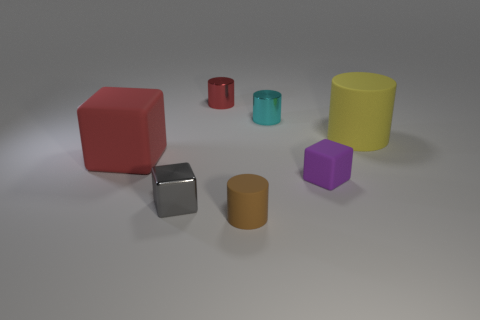Is there a red object to the right of the rubber cube that is behind the purple thing?
Make the answer very short. Yes. Are there fewer cyan shiny objects than rubber balls?
Offer a very short reply. No. How many big yellow objects have the same shape as the brown object?
Make the answer very short. 1. How many yellow things are either large metallic cylinders or big things?
Your answer should be very brief. 1. There is a rubber block that is to the right of the red object on the left side of the small gray metal block; what is its size?
Keep it short and to the point. Small. What is the material of the red thing that is the same shape as the big yellow rubber thing?
Your response must be concise. Metal. How many brown things are the same size as the yellow thing?
Your response must be concise. 0. Do the red metal object and the gray object have the same size?
Offer a very short reply. Yes. What is the size of the thing that is to the right of the tiny gray object and in front of the small matte cube?
Provide a short and direct response. Small. Are there more tiny shiny cylinders to the right of the small cyan metallic thing than shiny cylinders in front of the red rubber thing?
Ensure brevity in your answer.  No. 